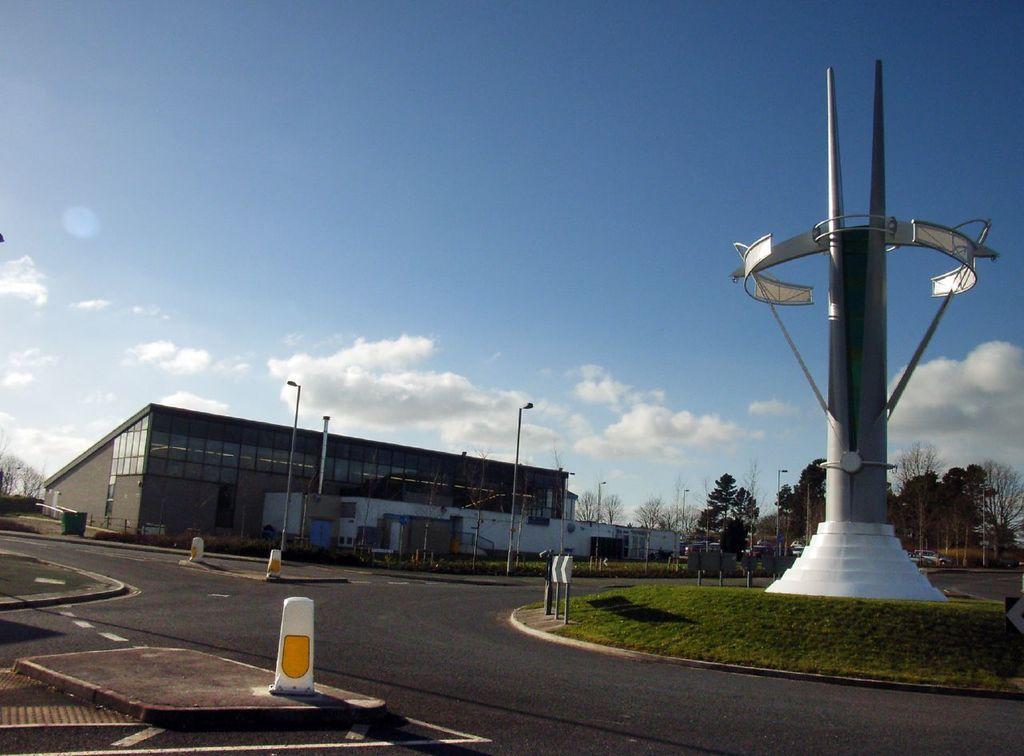Describe this image in one or two sentences. In this image, on the right, there is a tower and there are divider cones, poles and lights are on the road and in the background, there are buildings and trees. At the top, there are clouds in the sky. 